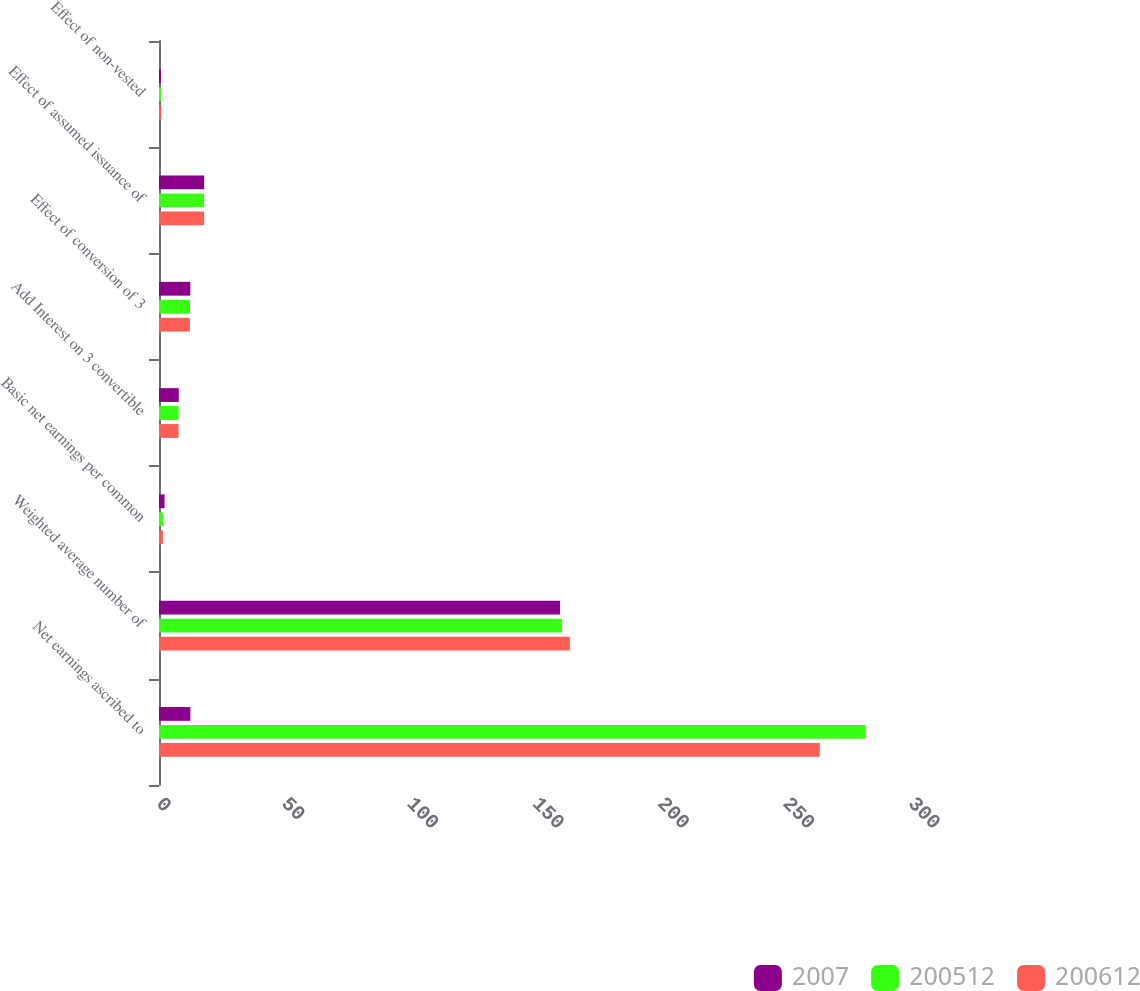Convert chart. <chart><loc_0><loc_0><loc_500><loc_500><stacked_bar_chart><ecel><fcel>Net earnings ascribed to<fcel>Weighted average number of<fcel>Basic net earnings per common<fcel>Add Interest on 3 convertible<fcel>Effect of conversion of 3<fcel>Effect of assumed issuance of<fcel>Effect of non-vested<nl><fcel>2007<fcel>12.5<fcel>160<fcel>2.21<fcel>7.9<fcel>12.5<fcel>18<fcel>0.8<nl><fcel>200512<fcel>281.9<fcel>160.8<fcel>1.7<fcel>7.8<fcel>12.4<fcel>18<fcel>0.8<nl><fcel>200612<fcel>263.6<fcel>163.9<fcel>1.56<fcel>7.8<fcel>12.3<fcel>18<fcel>0.9<nl></chart> 